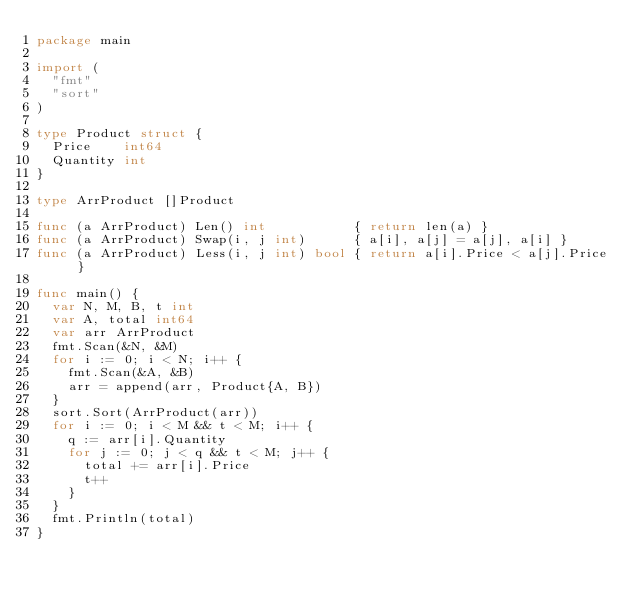<code> <loc_0><loc_0><loc_500><loc_500><_Go_>package main

import (
	"fmt"
	"sort"
)

type Product struct {
	Price    int64
	Quantity int
}

type ArrProduct []Product

func (a ArrProduct) Len() int           { return len(a) }
func (a ArrProduct) Swap(i, j int)      { a[i], a[j] = a[j], a[i] }
func (a ArrProduct) Less(i, j int) bool { return a[i].Price < a[j].Price }

func main() {
	var N, M, B, t int
	var A, total int64
	var arr ArrProduct
	fmt.Scan(&N, &M)
	for i := 0; i < N; i++ {
		fmt.Scan(&A, &B)
		arr = append(arr, Product{A, B})
	}
	sort.Sort(ArrProduct(arr))
	for i := 0; i < M && t < M; i++ {
		q := arr[i].Quantity
		for j := 0; j < q && t < M; j++ {
			total += arr[i].Price
			t++
		}
	}
	fmt.Println(total)
}</code> 